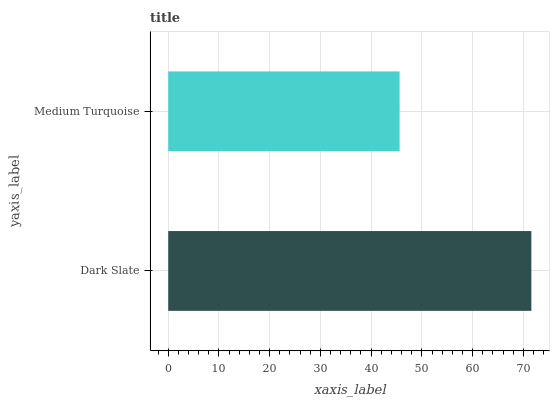Is Medium Turquoise the minimum?
Answer yes or no. Yes. Is Dark Slate the maximum?
Answer yes or no. Yes. Is Medium Turquoise the maximum?
Answer yes or no. No. Is Dark Slate greater than Medium Turquoise?
Answer yes or no. Yes. Is Medium Turquoise less than Dark Slate?
Answer yes or no. Yes. Is Medium Turquoise greater than Dark Slate?
Answer yes or no. No. Is Dark Slate less than Medium Turquoise?
Answer yes or no. No. Is Dark Slate the high median?
Answer yes or no. Yes. Is Medium Turquoise the low median?
Answer yes or no. Yes. Is Medium Turquoise the high median?
Answer yes or no. No. Is Dark Slate the low median?
Answer yes or no. No. 